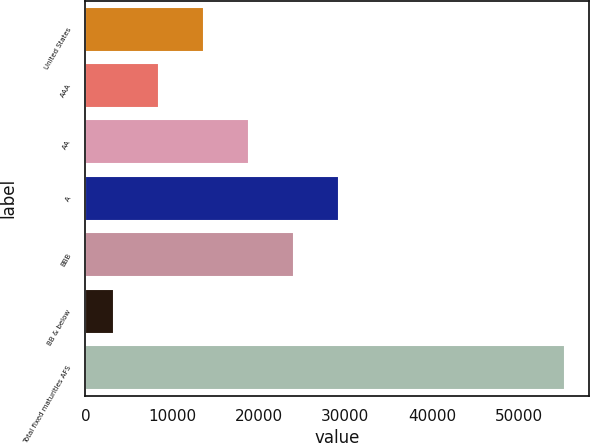<chart> <loc_0><loc_0><loc_500><loc_500><bar_chart><fcel>United States<fcel>AAA<fcel>AA<fcel>A<fcel>BBB<fcel>BB & below<fcel>Total fixed maturities AFS<nl><fcel>13706<fcel>8499<fcel>18913<fcel>29327<fcel>24120<fcel>3292<fcel>55362<nl></chart> 